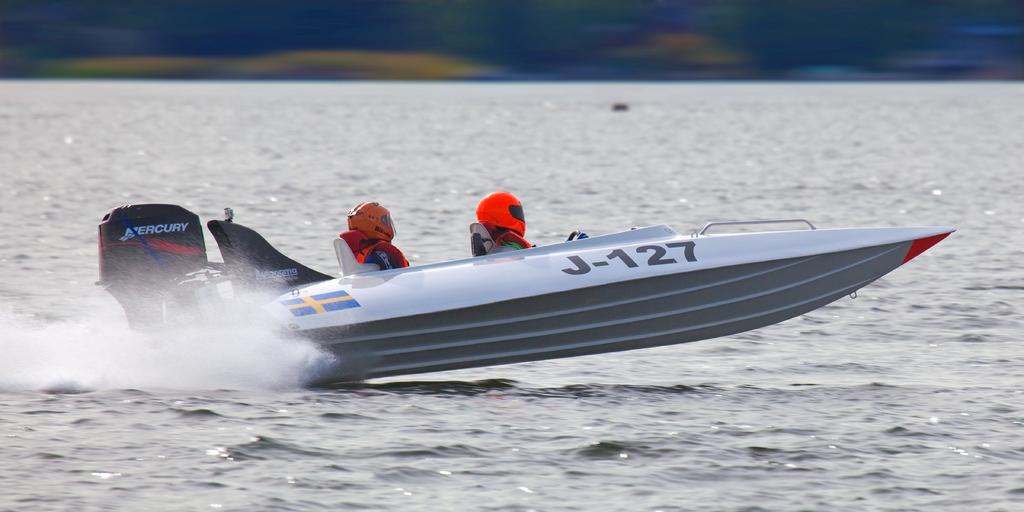What kind of motor do they have?
Keep it short and to the point. Mercury. What is the model number printed on the side of the boat?
Your answer should be compact. J-127. 